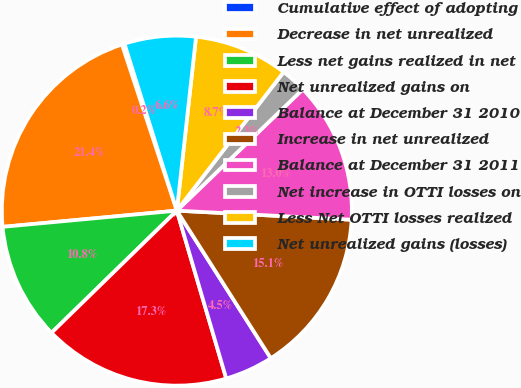Convert chart to OTSL. <chart><loc_0><loc_0><loc_500><loc_500><pie_chart><fcel>Cumulative effect of adopting<fcel>Decrease in net unrealized<fcel>Less net gains realized in net<fcel>Net unrealized gains on<fcel>Balance at December 31 2010<fcel>Increase in net unrealized<fcel>Balance at December 31 2011<fcel>Net increase in OTTI losses on<fcel>Less Net OTTI losses realized<fcel>Net unrealized gains (losses)<nl><fcel>0.24%<fcel>21.4%<fcel>10.82%<fcel>17.26%<fcel>4.47%<fcel>15.15%<fcel>13.03%<fcel>2.35%<fcel>8.7%<fcel>6.59%<nl></chart> 